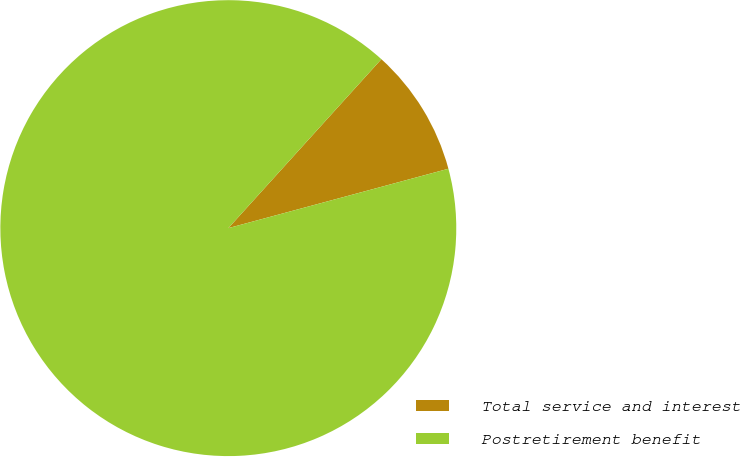<chart> <loc_0><loc_0><loc_500><loc_500><pie_chart><fcel>Total service and interest<fcel>Postretirement benefit<nl><fcel>9.09%<fcel>90.91%<nl></chart> 